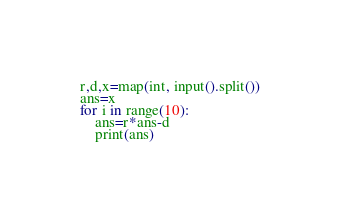Convert code to text. <code><loc_0><loc_0><loc_500><loc_500><_Python_>r,d,x=map(int, input().split())
ans=x
for i in range(10):
    ans=r*ans-d
    print(ans)</code> 